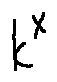<formula> <loc_0><loc_0><loc_500><loc_500>k ^ { X }</formula> 